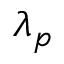Convert formula to latex. <formula><loc_0><loc_0><loc_500><loc_500>\lambda _ { p }</formula> 